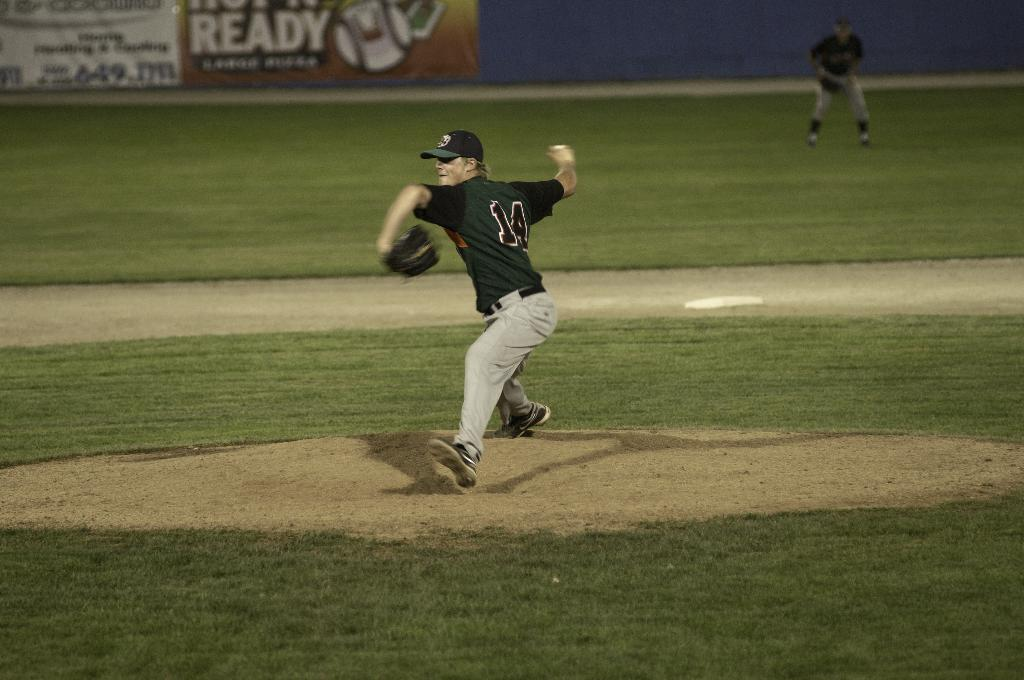<image>
Provide a brief description of the given image. Player number 14 is the pitcher and is about to throw a ball. 